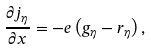Convert formula to latex. <formula><loc_0><loc_0><loc_500><loc_500>\frac { \partial j _ { \eta } } { \partial x } = - e \left ( g _ { \eta } - r _ { \eta } \right ) ,</formula> 